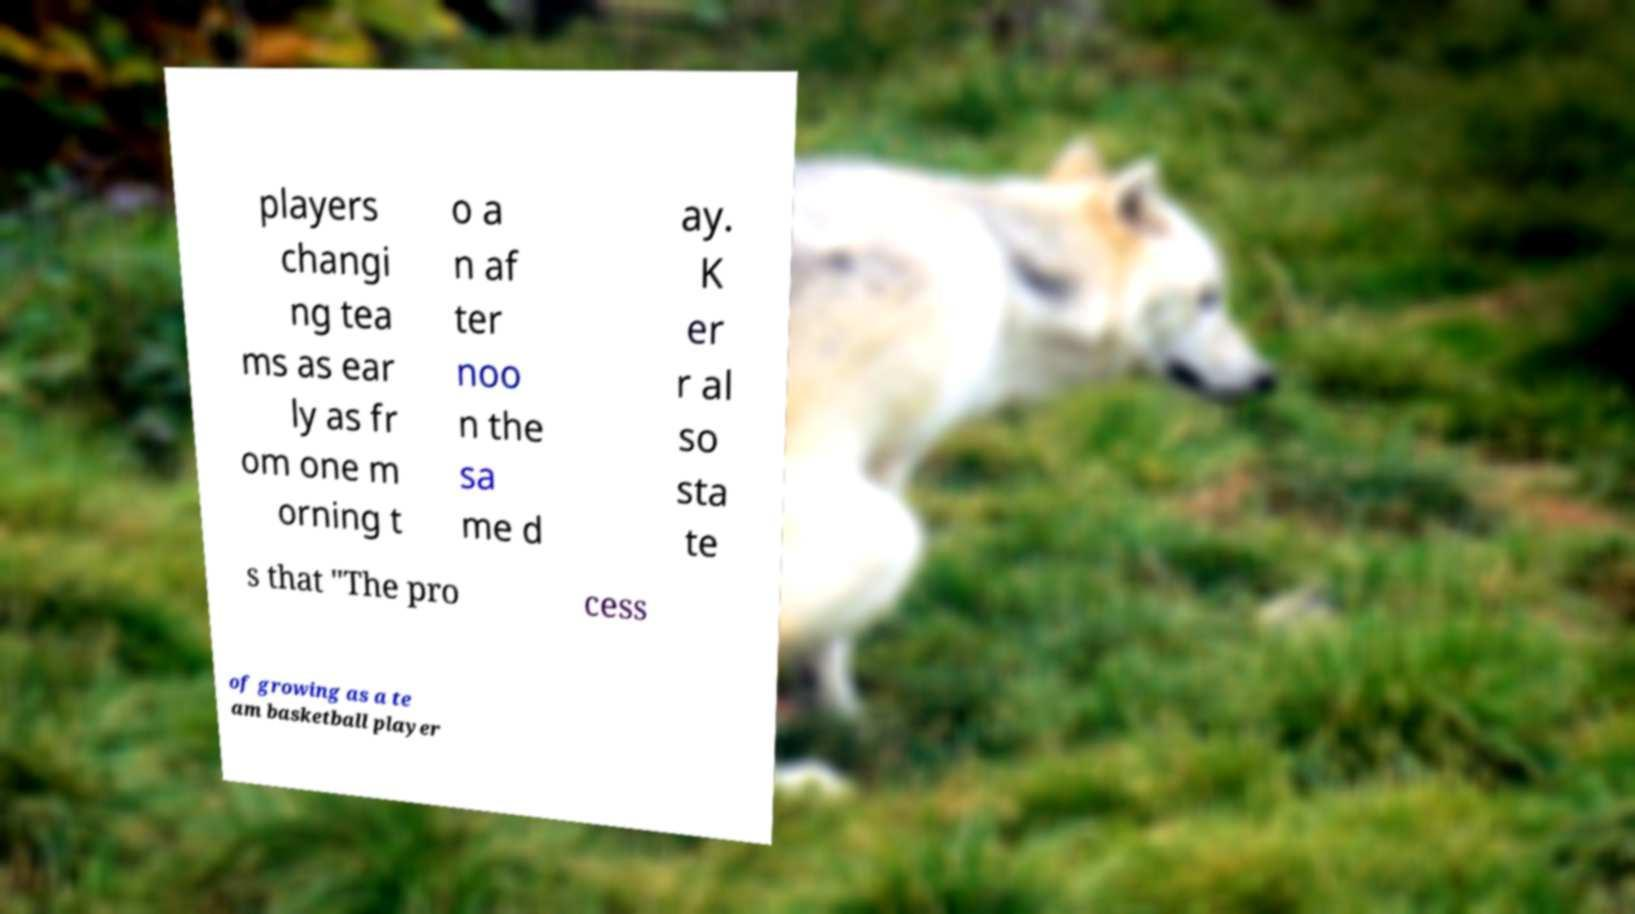Can you read and provide the text displayed in the image?This photo seems to have some interesting text. Can you extract and type it out for me? players changi ng tea ms as ear ly as fr om one m orning t o a n af ter noo n the sa me d ay. K er r al so sta te s that "The pro cess of growing as a te am basketball player 